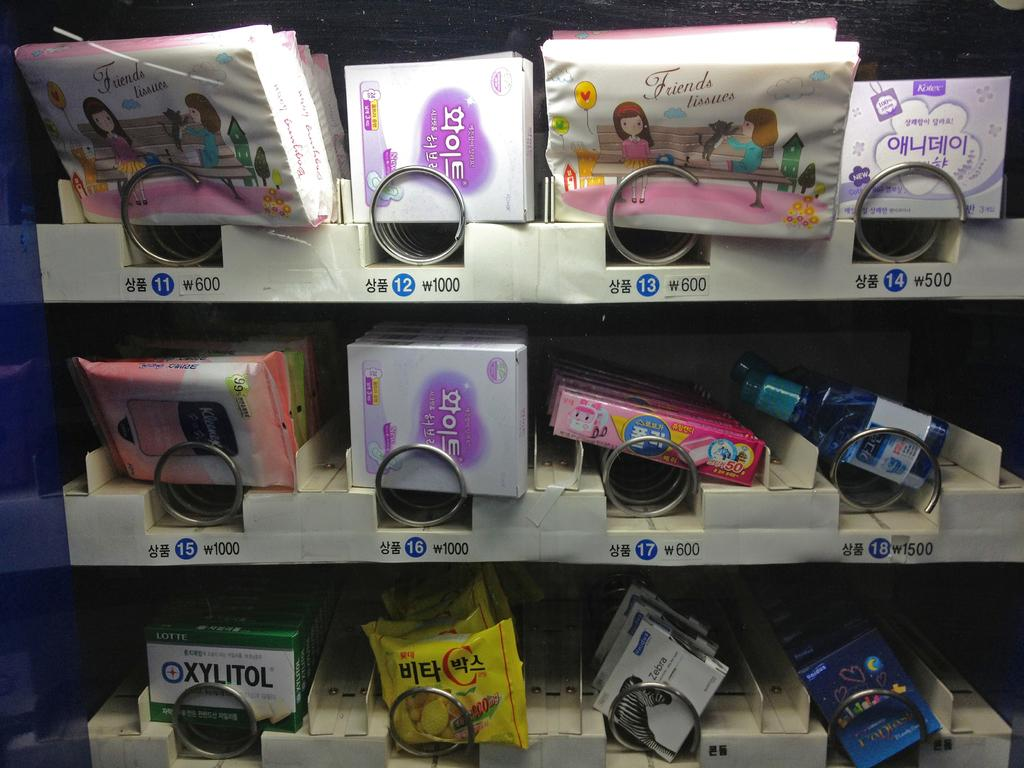What type of storage units are present in the image? There are shelves in the image. What items can be found on the shelves? The shelves contain boxes and bottles. Can you describe the variety of items on the shelves? There are different items on the shelves. What type of house does the queen live in, as depicted in the image? There is no house or queen present in the image; it only features shelves with boxes and bottles. 